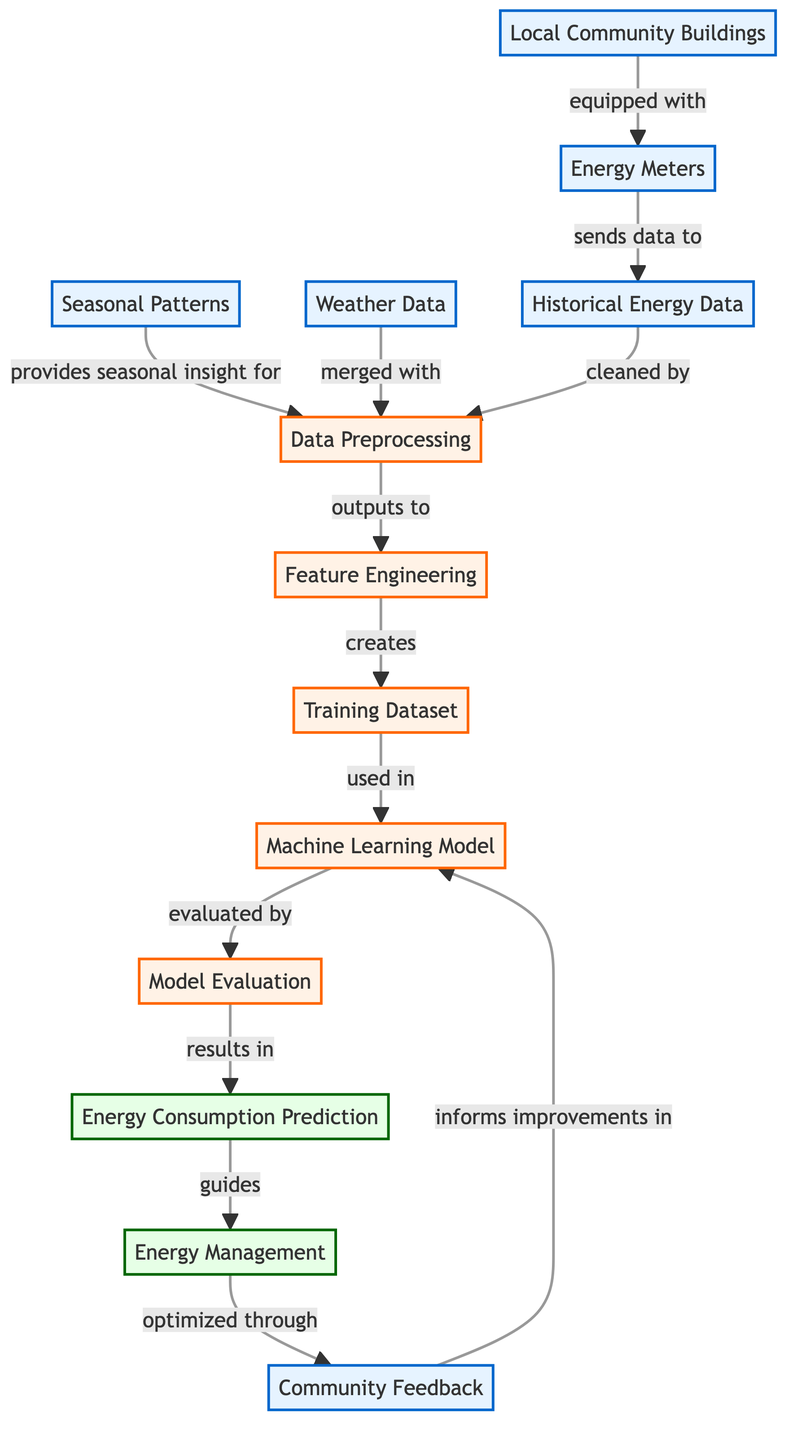What are the input nodes in the diagram? The input nodes are Local Community Buildings, Energy Meters, Historical Energy Data, Seasonal Patterns, Weather Data, and Community Feedback. These nodes are specifically categorized as inputs in the diagram.
Answer: Local Community Buildings, Energy Meters, Historical Energy Data, Seasonal Patterns, Weather Data, Community Feedback What process follows Data Preprocessing? After Data Preprocessing, the next step in the diagram is Feature Engineering, indicated by the arrow that moves from Data Preprocessing to Feature Engineering.
Answer: Feature Engineering How many output nodes are present in the diagram? The diagram shows two output nodes: Energy Consumption Prediction and Energy Management. Counting these gives a total of two.
Answer: 2 What nodes provide data to Data Preprocessing? The nodes that provide data to Data Preprocessing are Seasonal Patterns, Weather Data, and Historical Energy Data, as all of these connect to Data Preprocessing.
Answer: Seasonal Patterns, Weather Data, Historical Energy Data Which node is evaluated to produce Energy Consumption Prediction? The node that is evaluated to produce Energy Consumption Prediction is the Machine Learning Model, as it is the one that directly connects to the Model Evaluation node to result in Energy Consumption Prediction.
Answer: Machine Learning Model How does Community Feedback influence the diagram? Community Feedback guides Energy Management and also informs improvements in the Machine Learning Model, creating a feedback loop in the process.
Answer: Guides Energy Management, informs improvements in Machine Learning Model What initiates the feature engineering process? The feature engineering process is initiated by the output from Data Preprocessing, which is the cleaned data.
Answer: Data Preprocessing What is the final output of the diagram? The final outputs of the diagram are Energy Consumption Prediction and Energy Management, as both nodes are at the end of the flow.
Answer: Energy Consumption Prediction and Energy Management 